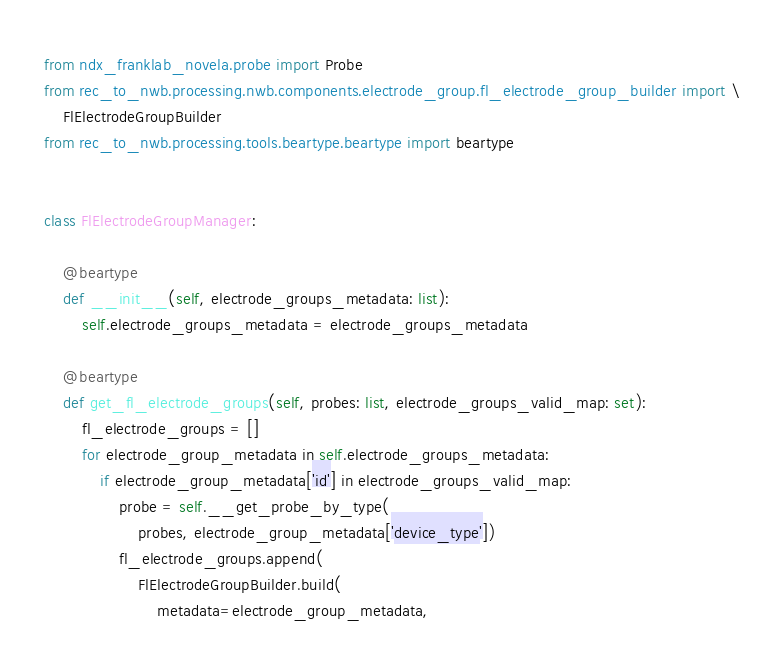<code> <loc_0><loc_0><loc_500><loc_500><_Python_>from ndx_franklab_novela.probe import Probe
from rec_to_nwb.processing.nwb.components.electrode_group.fl_electrode_group_builder import \
    FlElectrodeGroupBuilder
from rec_to_nwb.processing.tools.beartype.beartype import beartype


class FlElectrodeGroupManager:

    @beartype
    def __init__(self, electrode_groups_metadata: list):
        self.electrode_groups_metadata = electrode_groups_metadata

    @beartype
    def get_fl_electrode_groups(self, probes: list, electrode_groups_valid_map: set):
        fl_electrode_groups = []
        for electrode_group_metadata in self.electrode_groups_metadata:
            if electrode_group_metadata['id'] in electrode_groups_valid_map:
                probe = self.__get_probe_by_type(
                    probes, electrode_group_metadata['device_type'])
                fl_electrode_groups.append(
                    FlElectrodeGroupBuilder.build(
                        metadata=electrode_group_metadata,</code> 